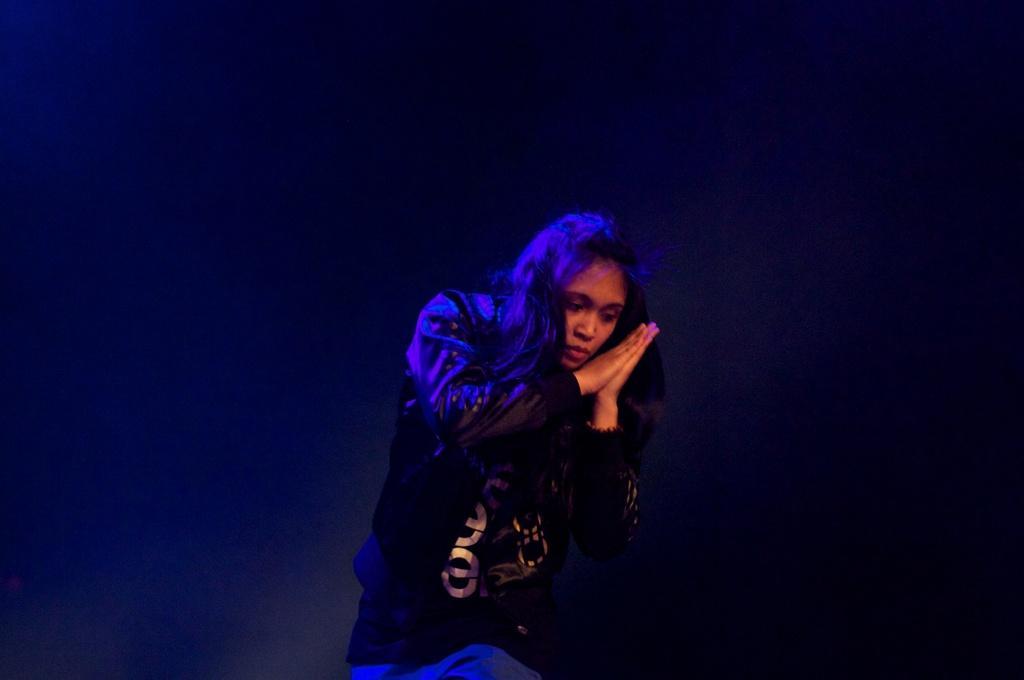Can you describe this image briefly? In the image we can see there is a person standing and she is holding her palms. Background of the image is dark. 